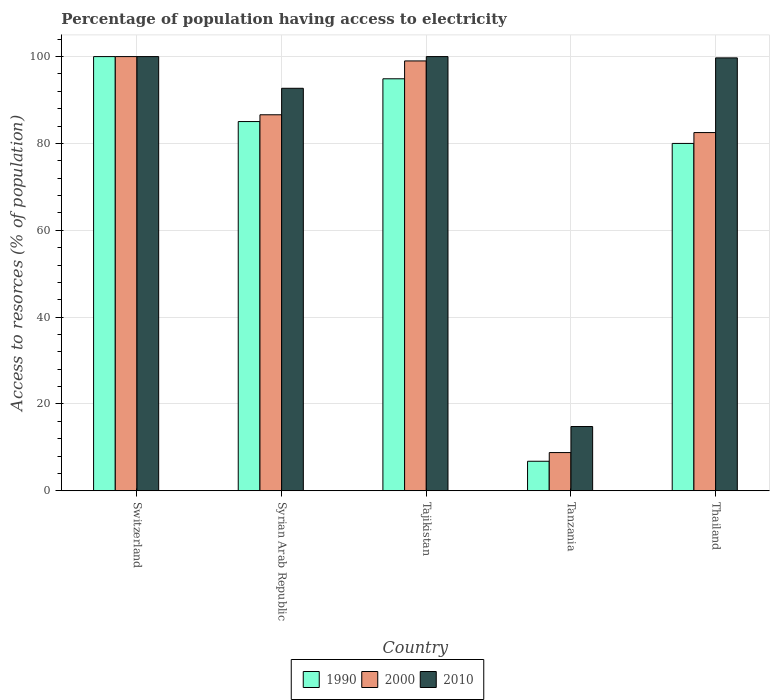How many groups of bars are there?
Your answer should be very brief. 5. Are the number of bars per tick equal to the number of legend labels?
Provide a short and direct response. Yes. Are the number of bars on each tick of the X-axis equal?
Your answer should be compact. Yes. How many bars are there on the 5th tick from the left?
Give a very brief answer. 3. How many bars are there on the 4th tick from the right?
Your answer should be compact. 3. What is the label of the 5th group of bars from the left?
Your answer should be very brief. Thailand. What is the percentage of population having access to electricity in 2010 in Thailand?
Ensure brevity in your answer.  99.7. Across all countries, what is the minimum percentage of population having access to electricity in 2000?
Your answer should be compact. 8.8. In which country was the percentage of population having access to electricity in 2010 maximum?
Your response must be concise. Switzerland. In which country was the percentage of population having access to electricity in 1990 minimum?
Keep it short and to the point. Tanzania. What is the total percentage of population having access to electricity in 1990 in the graph?
Offer a terse response. 366.73. What is the difference between the percentage of population having access to electricity in 2000 in Switzerland and that in Syrian Arab Republic?
Provide a succinct answer. 13.4. What is the difference between the percentage of population having access to electricity in 2010 in Syrian Arab Republic and the percentage of population having access to electricity in 2000 in Tanzania?
Offer a very short reply. 83.9. What is the average percentage of population having access to electricity in 1990 per country?
Offer a terse response. 73.35. What is the difference between the percentage of population having access to electricity of/in 2010 and percentage of population having access to electricity of/in 1990 in Tajikistan?
Offer a terse response. 5.11. In how many countries, is the percentage of population having access to electricity in 2000 greater than 100 %?
Offer a very short reply. 0. What is the ratio of the percentage of population having access to electricity in 1990 in Tanzania to that in Thailand?
Your answer should be compact. 0.08. Is the percentage of population having access to electricity in 1990 in Syrian Arab Republic less than that in Tajikistan?
Keep it short and to the point. Yes. What is the difference between the highest and the second highest percentage of population having access to electricity in 2010?
Provide a short and direct response. -0.3. What is the difference between the highest and the lowest percentage of population having access to electricity in 2000?
Make the answer very short. 91.2. Is it the case that in every country, the sum of the percentage of population having access to electricity in 2000 and percentage of population having access to electricity in 1990 is greater than the percentage of population having access to electricity in 2010?
Provide a short and direct response. Yes. Are all the bars in the graph horizontal?
Keep it short and to the point. No. What is the difference between two consecutive major ticks on the Y-axis?
Make the answer very short. 20. Are the values on the major ticks of Y-axis written in scientific E-notation?
Your answer should be very brief. No. Does the graph contain any zero values?
Your response must be concise. No. Where does the legend appear in the graph?
Offer a terse response. Bottom center. How are the legend labels stacked?
Make the answer very short. Horizontal. What is the title of the graph?
Offer a terse response. Percentage of population having access to electricity. What is the label or title of the X-axis?
Offer a very short reply. Country. What is the label or title of the Y-axis?
Ensure brevity in your answer.  Access to resorces (% of population). What is the Access to resorces (% of population) in 1990 in Syrian Arab Republic?
Your response must be concise. 85.04. What is the Access to resorces (% of population) in 2000 in Syrian Arab Republic?
Make the answer very short. 86.6. What is the Access to resorces (% of population) of 2010 in Syrian Arab Republic?
Offer a very short reply. 92.7. What is the Access to resorces (% of population) in 1990 in Tajikistan?
Your answer should be compact. 94.89. What is the Access to resorces (% of population) in 2000 in Tajikistan?
Offer a terse response. 99. What is the Access to resorces (% of population) in 2010 in Tajikistan?
Your answer should be compact. 100. What is the Access to resorces (% of population) of 1990 in Tanzania?
Your answer should be compact. 6.8. What is the Access to resorces (% of population) in 2010 in Tanzania?
Provide a short and direct response. 14.8. What is the Access to resorces (% of population) in 2000 in Thailand?
Provide a succinct answer. 82.5. What is the Access to resorces (% of population) in 2010 in Thailand?
Offer a very short reply. 99.7. Across all countries, what is the maximum Access to resorces (% of population) of 1990?
Give a very brief answer. 100. Across all countries, what is the maximum Access to resorces (% of population) of 2010?
Offer a very short reply. 100. Across all countries, what is the minimum Access to resorces (% of population) in 2000?
Provide a succinct answer. 8.8. What is the total Access to resorces (% of population) in 1990 in the graph?
Give a very brief answer. 366.73. What is the total Access to resorces (% of population) of 2000 in the graph?
Ensure brevity in your answer.  376.9. What is the total Access to resorces (% of population) in 2010 in the graph?
Keep it short and to the point. 407.2. What is the difference between the Access to resorces (% of population) of 1990 in Switzerland and that in Syrian Arab Republic?
Your answer should be very brief. 14.96. What is the difference between the Access to resorces (% of population) of 2010 in Switzerland and that in Syrian Arab Republic?
Your response must be concise. 7.3. What is the difference between the Access to resorces (% of population) in 1990 in Switzerland and that in Tajikistan?
Give a very brief answer. 5.11. What is the difference between the Access to resorces (% of population) in 1990 in Switzerland and that in Tanzania?
Make the answer very short. 93.2. What is the difference between the Access to resorces (% of population) in 2000 in Switzerland and that in Tanzania?
Your answer should be compact. 91.2. What is the difference between the Access to resorces (% of population) in 2010 in Switzerland and that in Tanzania?
Keep it short and to the point. 85.2. What is the difference between the Access to resorces (% of population) of 2010 in Switzerland and that in Thailand?
Provide a short and direct response. 0.3. What is the difference between the Access to resorces (% of population) in 1990 in Syrian Arab Republic and that in Tajikistan?
Give a very brief answer. -9.85. What is the difference between the Access to resorces (% of population) of 2000 in Syrian Arab Republic and that in Tajikistan?
Offer a terse response. -12.4. What is the difference between the Access to resorces (% of population) of 1990 in Syrian Arab Republic and that in Tanzania?
Offer a very short reply. 78.24. What is the difference between the Access to resorces (% of population) of 2000 in Syrian Arab Republic and that in Tanzania?
Provide a succinct answer. 77.8. What is the difference between the Access to resorces (% of population) of 2010 in Syrian Arab Republic and that in Tanzania?
Give a very brief answer. 77.9. What is the difference between the Access to resorces (% of population) of 1990 in Syrian Arab Republic and that in Thailand?
Offer a terse response. 5.04. What is the difference between the Access to resorces (% of population) of 1990 in Tajikistan and that in Tanzania?
Provide a succinct answer. 88.09. What is the difference between the Access to resorces (% of population) of 2000 in Tajikistan and that in Tanzania?
Offer a very short reply. 90.2. What is the difference between the Access to resorces (% of population) of 2010 in Tajikistan and that in Tanzania?
Make the answer very short. 85.2. What is the difference between the Access to resorces (% of population) in 1990 in Tajikistan and that in Thailand?
Your answer should be very brief. 14.89. What is the difference between the Access to resorces (% of population) of 2000 in Tajikistan and that in Thailand?
Offer a terse response. 16.5. What is the difference between the Access to resorces (% of population) in 2010 in Tajikistan and that in Thailand?
Provide a short and direct response. 0.3. What is the difference between the Access to resorces (% of population) of 1990 in Tanzania and that in Thailand?
Offer a terse response. -73.2. What is the difference between the Access to resorces (% of population) in 2000 in Tanzania and that in Thailand?
Provide a succinct answer. -73.7. What is the difference between the Access to resorces (% of population) in 2010 in Tanzania and that in Thailand?
Provide a short and direct response. -84.9. What is the difference between the Access to resorces (% of population) of 1990 in Switzerland and the Access to resorces (% of population) of 2010 in Syrian Arab Republic?
Offer a terse response. 7.3. What is the difference between the Access to resorces (% of population) in 2000 in Switzerland and the Access to resorces (% of population) in 2010 in Syrian Arab Republic?
Make the answer very short. 7.3. What is the difference between the Access to resorces (% of population) of 1990 in Switzerland and the Access to resorces (% of population) of 2000 in Tajikistan?
Your answer should be compact. 1. What is the difference between the Access to resorces (% of population) of 1990 in Switzerland and the Access to resorces (% of population) of 2010 in Tajikistan?
Your answer should be very brief. 0. What is the difference between the Access to resorces (% of population) in 2000 in Switzerland and the Access to resorces (% of population) in 2010 in Tajikistan?
Your response must be concise. 0. What is the difference between the Access to resorces (% of population) in 1990 in Switzerland and the Access to resorces (% of population) in 2000 in Tanzania?
Provide a succinct answer. 91.2. What is the difference between the Access to resorces (% of population) in 1990 in Switzerland and the Access to resorces (% of population) in 2010 in Tanzania?
Provide a succinct answer. 85.2. What is the difference between the Access to resorces (% of population) in 2000 in Switzerland and the Access to resorces (% of population) in 2010 in Tanzania?
Make the answer very short. 85.2. What is the difference between the Access to resorces (% of population) of 1990 in Switzerland and the Access to resorces (% of population) of 2010 in Thailand?
Keep it short and to the point. 0.3. What is the difference between the Access to resorces (% of population) of 2000 in Switzerland and the Access to resorces (% of population) of 2010 in Thailand?
Provide a succinct answer. 0.3. What is the difference between the Access to resorces (% of population) in 1990 in Syrian Arab Republic and the Access to resorces (% of population) in 2000 in Tajikistan?
Give a very brief answer. -13.96. What is the difference between the Access to resorces (% of population) in 1990 in Syrian Arab Republic and the Access to resorces (% of population) in 2010 in Tajikistan?
Provide a short and direct response. -14.96. What is the difference between the Access to resorces (% of population) in 1990 in Syrian Arab Republic and the Access to resorces (% of population) in 2000 in Tanzania?
Your answer should be very brief. 76.24. What is the difference between the Access to resorces (% of population) in 1990 in Syrian Arab Republic and the Access to resorces (% of population) in 2010 in Tanzania?
Your response must be concise. 70.24. What is the difference between the Access to resorces (% of population) of 2000 in Syrian Arab Republic and the Access to resorces (% of population) of 2010 in Tanzania?
Ensure brevity in your answer.  71.8. What is the difference between the Access to resorces (% of population) in 1990 in Syrian Arab Republic and the Access to resorces (% of population) in 2000 in Thailand?
Give a very brief answer. 2.54. What is the difference between the Access to resorces (% of population) in 1990 in Syrian Arab Republic and the Access to resorces (% of population) in 2010 in Thailand?
Offer a very short reply. -14.66. What is the difference between the Access to resorces (% of population) of 2000 in Syrian Arab Republic and the Access to resorces (% of population) of 2010 in Thailand?
Provide a short and direct response. -13.1. What is the difference between the Access to resorces (% of population) in 1990 in Tajikistan and the Access to resorces (% of population) in 2000 in Tanzania?
Your response must be concise. 86.09. What is the difference between the Access to resorces (% of population) of 1990 in Tajikistan and the Access to resorces (% of population) of 2010 in Tanzania?
Make the answer very short. 80.09. What is the difference between the Access to resorces (% of population) in 2000 in Tajikistan and the Access to resorces (% of population) in 2010 in Tanzania?
Offer a terse response. 84.2. What is the difference between the Access to resorces (% of population) in 1990 in Tajikistan and the Access to resorces (% of population) in 2000 in Thailand?
Keep it short and to the point. 12.39. What is the difference between the Access to resorces (% of population) in 1990 in Tajikistan and the Access to resorces (% of population) in 2010 in Thailand?
Offer a very short reply. -4.81. What is the difference between the Access to resorces (% of population) of 1990 in Tanzania and the Access to resorces (% of population) of 2000 in Thailand?
Provide a short and direct response. -75.7. What is the difference between the Access to resorces (% of population) of 1990 in Tanzania and the Access to resorces (% of population) of 2010 in Thailand?
Provide a succinct answer. -92.9. What is the difference between the Access to resorces (% of population) in 2000 in Tanzania and the Access to resorces (% of population) in 2010 in Thailand?
Give a very brief answer. -90.9. What is the average Access to resorces (% of population) in 1990 per country?
Give a very brief answer. 73.35. What is the average Access to resorces (% of population) in 2000 per country?
Your answer should be very brief. 75.38. What is the average Access to resorces (% of population) of 2010 per country?
Your response must be concise. 81.44. What is the difference between the Access to resorces (% of population) in 1990 and Access to resorces (% of population) in 2000 in Syrian Arab Republic?
Make the answer very short. -1.56. What is the difference between the Access to resorces (% of population) of 1990 and Access to resorces (% of population) of 2010 in Syrian Arab Republic?
Provide a short and direct response. -7.66. What is the difference between the Access to resorces (% of population) in 2000 and Access to resorces (% of population) in 2010 in Syrian Arab Republic?
Make the answer very short. -6.1. What is the difference between the Access to resorces (% of population) in 1990 and Access to resorces (% of population) in 2000 in Tajikistan?
Keep it short and to the point. -4.11. What is the difference between the Access to resorces (% of population) in 1990 and Access to resorces (% of population) in 2010 in Tajikistan?
Ensure brevity in your answer.  -5.11. What is the difference between the Access to resorces (% of population) in 2000 and Access to resorces (% of population) in 2010 in Tajikistan?
Your answer should be very brief. -1. What is the difference between the Access to resorces (% of population) of 1990 and Access to resorces (% of population) of 2010 in Tanzania?
Offer a terse response. -8. What is the difference between the Access to resorces (% of population) of 1990 and Access to resorces (% of population) of 2000 in Thailand?
Offer a terse response. -2.5. What is the difference between the Access to resorces (% of population) in 1990 and Access to resorces (% of population) in 2010 in Thailand?
Offer a very short reply. -19.7. What is the difference between the Access to resorces (% of population) in 2000 and Access to resorces (% of population) in 2010 in Thailand?
Provide a succinct answer. -17.2. What is the ratio of the Access to resorces (% of population) in 1990 in Switzerland to that in Syrian Arab Republic?
Make the answer very short. 1.18. What is the ratio of the Access to resorces (% of population) in 2000 in Switzerland to that in Syrian Arab Republic?
Offer a terse response. 1.15. What is the ratio of the Access to resorces (% of population) of 2010 in Switzerland to that in Syrian Arab Republic?
Make the answer very short. 1.08. What is the ratio of the Access to resorces (% of population) of 1990 in Switzerland to that in Tajikistan?
Ensure brevity in your answer.  1.05. What is the ratio of the Access to resorces (% of population) of 2000 in Switzerland to that in Tajikistan?
Your answer should be compact. 1.01. What is the ratio of the Access to resorces (% of population) of 2010 in Switzerland to that in Tajikistan?
Ensure brevity in your answer.  1. What is the ratio of the Access to resorces (% of population) of 1990 in Switzerland to that in Tanzania?
Provide a succinct answer. 14.71. What is the ratio of the Access to resorces (% of population) in 2000 in Switzerland to that in Tanzania?
Your answer should be very brief. 11.36. What is the ratio of the Access to resorces (% of population) in 2010 in Switzerland to that in Tanzania?
Make the answer very short. 6.76. What is the ratio of the Access to resorces (% of population) in 1990 in Switzerland to that in Thailand?
Make the answer very short. 1.25. What is the ratio of the Access to resorces (% of population) of 2000 in Switzerland to that in Thailand?
Offer a terse response. 1.21. What is the ratio of the Access to resorces (% of population) of 2010 in Switzerland to that in Thailand?
Offer a very short reply. 1. What is the ratio of the Access to resorces (% of population) in 1990 in Syrian Arab Republic to that in Tajikistan?
Your response must be concise. 0.9. What is the ratio of the Access to resorces (% of population) in 2000 in Syrian Arab Republic to that in Tajikistan?
Ensure brevity in your answer.  0.87. What is the ratio of the Access to resorces (% of population) of 2010 in Syrian Arab Republic to that in Tajikistan?
Ensure brevity in your answer.  0.93. What is the ratio of the Access to resorces (% of population) of 1990 in Syrian Arab Republic to that in Tanzania?
Your answer should be very brief. 12.51. What is the ratio of the Access to resorces (% of population) in 2000 in Syrian Arab Republic to that in Tanzania?
Provide a short and direct response. 9.84. What is the ratio of the Access to resorces (% of population) in 2010 in Syrian Arab Republic to that in Tanzania?
Your response must be concise. 6.26. What is the ratio of the Access to resorces (% of population) of 1990 in Syrian Arab Republic to that in Thailand?
Your response must be concise. 1.06. What is the ratio of the Access to resorces (% of population) of 2000 in Syrian Arab Republic to that in Thailand?
Your answer should be compact. 1.05. What is the ratio of the Access to resorces (% of population) of 2010 in Syrian Arab Republic to that in Thailand?
Ensure brevity in your answer.  0.93. What is the ratio of the Access to resorces (% of population) of 1990 in Tajikistan to that in Tanzania?
Keep it short and to the point. 13.95. What is the ratio of the Access to resorces (% of population) of 2000 in Tajikistan to that in Tanzania?
Your response must be concise. 11.25. What is the ratio of the Access to resorces (% of population) in 2010 in Tajikistan to that in Tanzania?
Keep it short and to the point. 6.76. What is the ratio of the Access to resorces (% of population) of 1990 in Tajikistan to that in Thailand?
Your answer should be very brief. 1.19. What is the ratio of the Access to resorces (% of population) of 2010 in Tajikistan to that in Thailand?
Offer a very short reply. 1. What is the ratio of the Access to resorces (% of population) of 1990 in Tanzania to that in Thailand?
Keep it short and to the point. 0.09. What is the ratio of the Access to resorces (% of population) in 2000 in Tanzania to that in Thailand?
Keep it short and to the point. 0.11. What is the ratio of the Access to resorces (% of population) of 2010 in Tanzania to that in Thailand?
Your answer should be very brief. 0.15. What is the difference between the highest and the second highest Access to resorces (% of population) of 1990?
Your answer should be very brief. 5.11. What is the difference between the highest and the second highest Access to resorces (% of population) in 2010?
Your answer should be compact. 0. What is the difference between the highest and the lowest Access to resorces (% of population) of 1990?
Keep it short and to the point. 93.2. What is the difference between the highest and the lowest Access to resorces (% of population) in 2000?
Ensure brevity in your answer.  91.2. What is the difference between the highest and the lowest Access to resorces (% of population) in 2010?
Offer a very short reply. 85.2. 